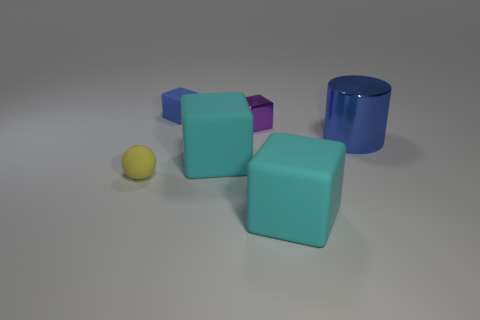Subtract all matte blocks. How many blocks are left? 1 Add 3 small yellow spheres. How many objects exist? 9 Subtract all yellow cylinders. How many cyan cubes are left? 2 Subtract all blue blocks. How many blocks are left? 3 Subtract all large gray metallic blocks. Subtract all big blue shiny things. How many objects are left? 5 Add 6 blue matte blocks. How many blue matte blocks are left? 7 Add 3 yellow matte cylinders. How many yellow matte cylinders exist? 3 Subtract 0 yellow cylinders. How many objects are left? 6 Subtract all balls. How many objects are left? 5 Subtract all brown cylinders. Subtract all red spheres. How many cylinders are left? 1 